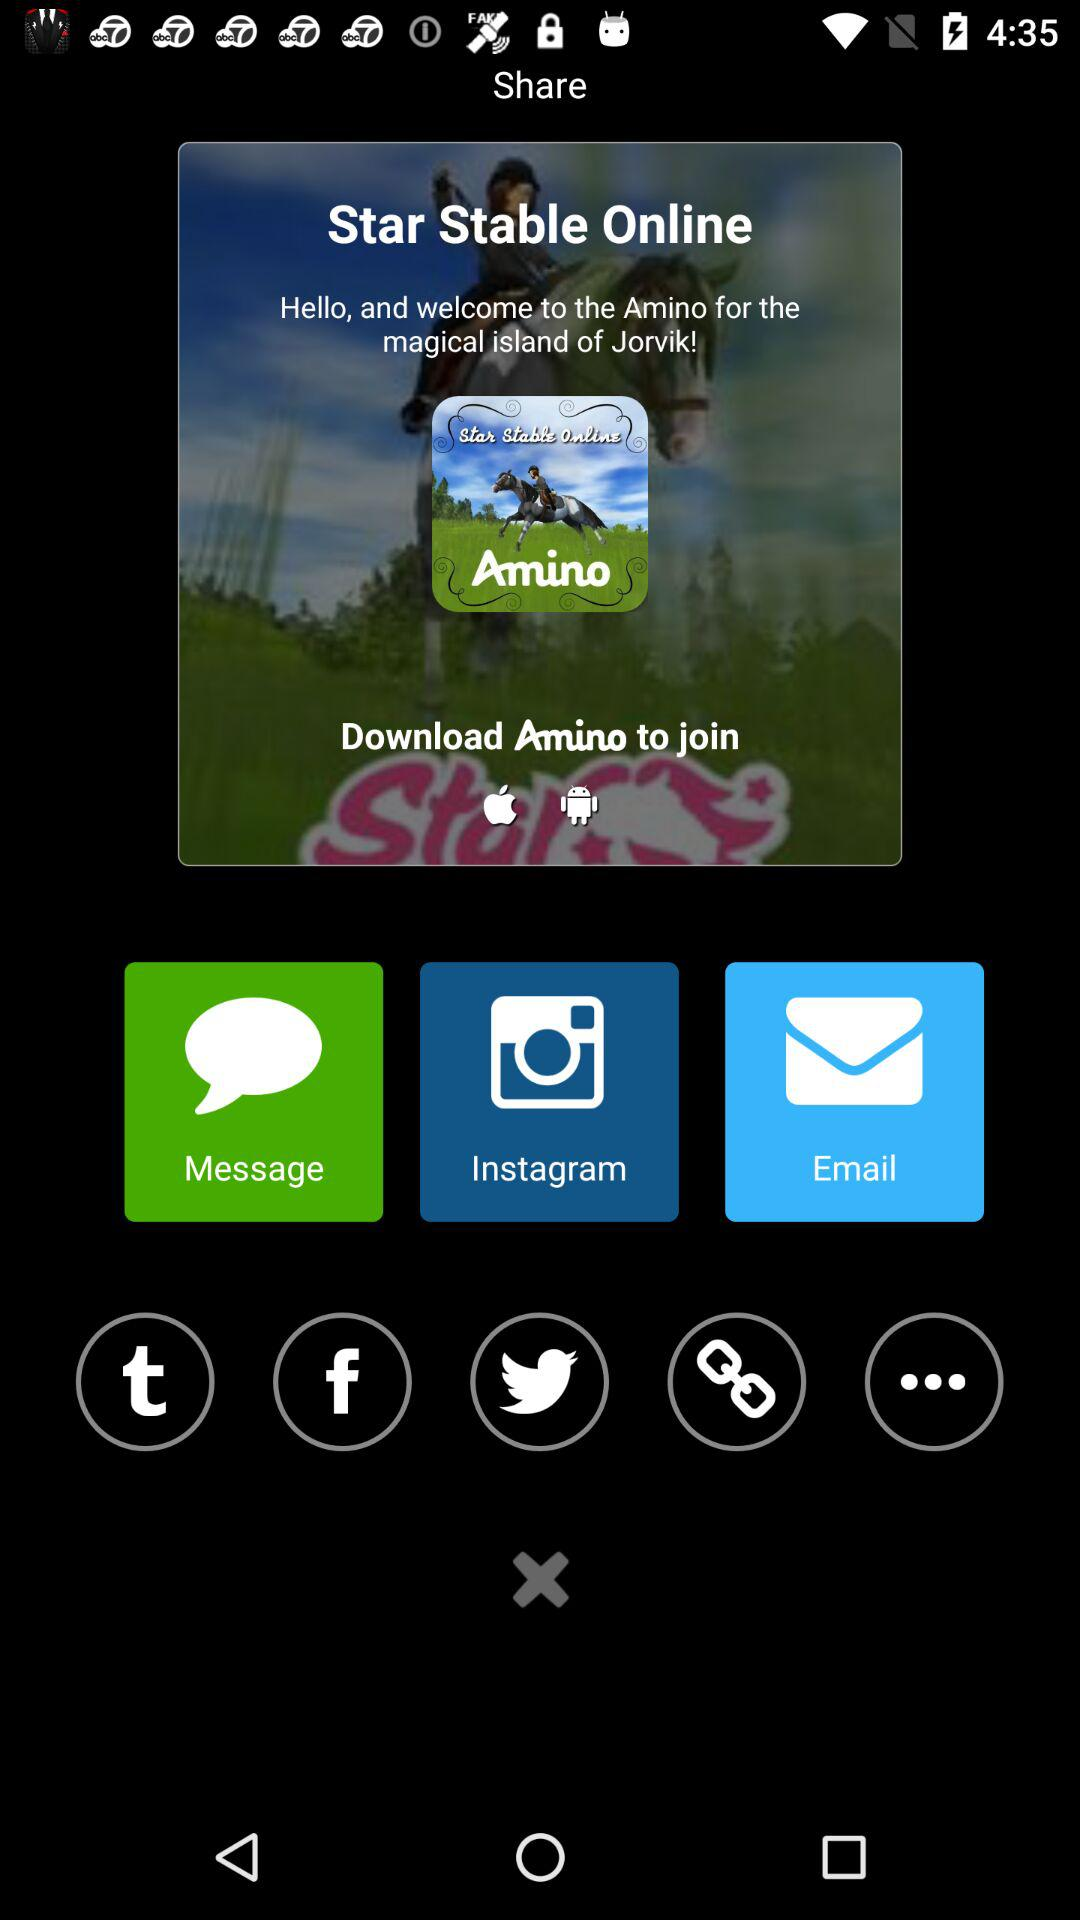What is the name of the application? The names of the applications are "Star Stable Online" and "Amino". 